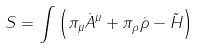Convert formula to latex. <formula><loc_0><loc_0><loc_500><loc_500>S = \int \left ( \pi _ { \mu } { \dot { A } } ^ { \mu } + \pi _ { \rho } { \dot { \rho } } - \tilde { H } \right )</formula> 